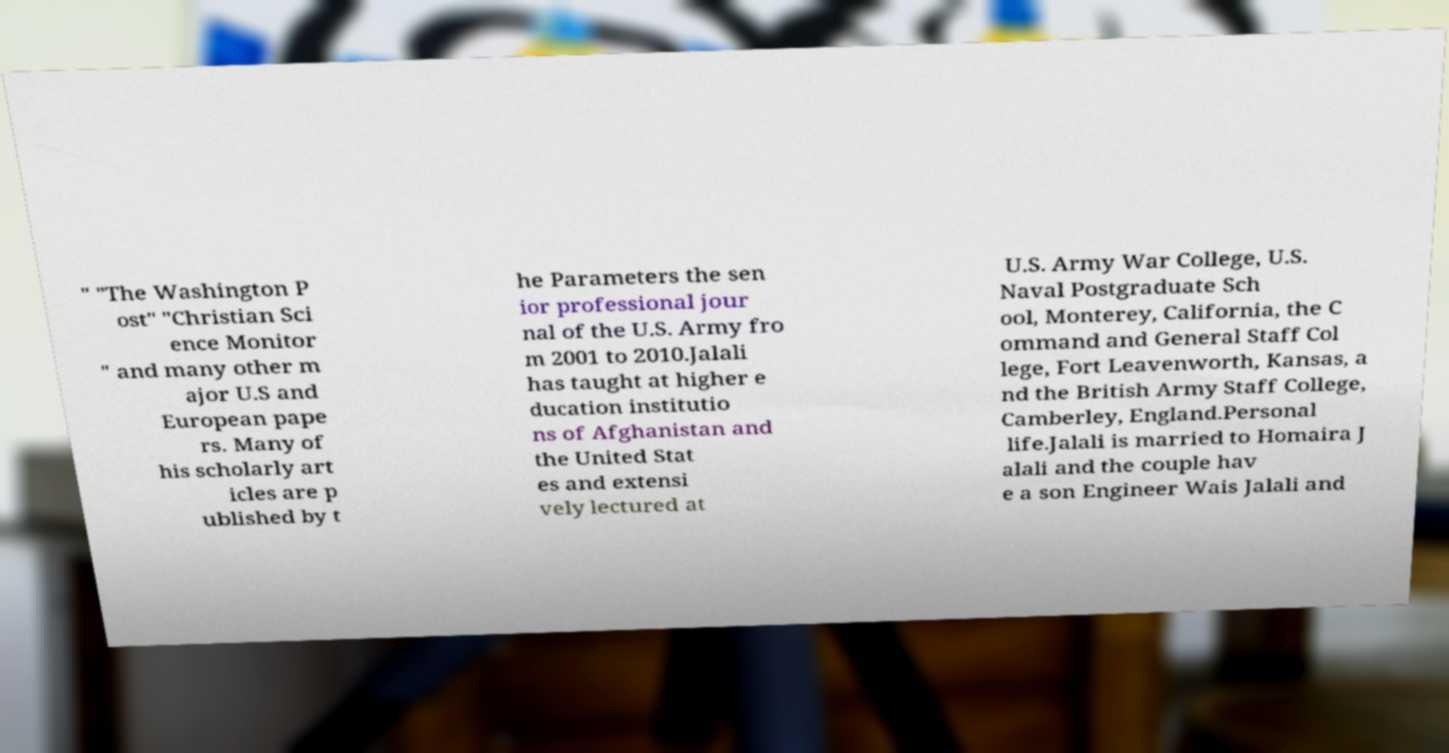Can you accurately transcribe the text from the provided image for me? " "The Washington P ost" "Christian Sci ence Monitor " and many other m ajor U.S and European pape rs. Many of his scholarly art icles are p ublished by t he Parameters the sen ior professional jour nal of the U.S. Army fro m 2001 to 2010.Jalali has taught at higher e ducation institutio ns of Afghanistan and the United Stat es and extensi vely lectured at U.S. Army War College, U.S. Naval Postgraduate Sch ool, Monterey, California, the C ommand and General Staff Col lege, Fort Leavenworth, Kansas, a nd the British Army Staff College, Camberley, England.Personal life.Jalali is married to Homaira J alali and the couple hav e a son Engineer Wais Jalali and 